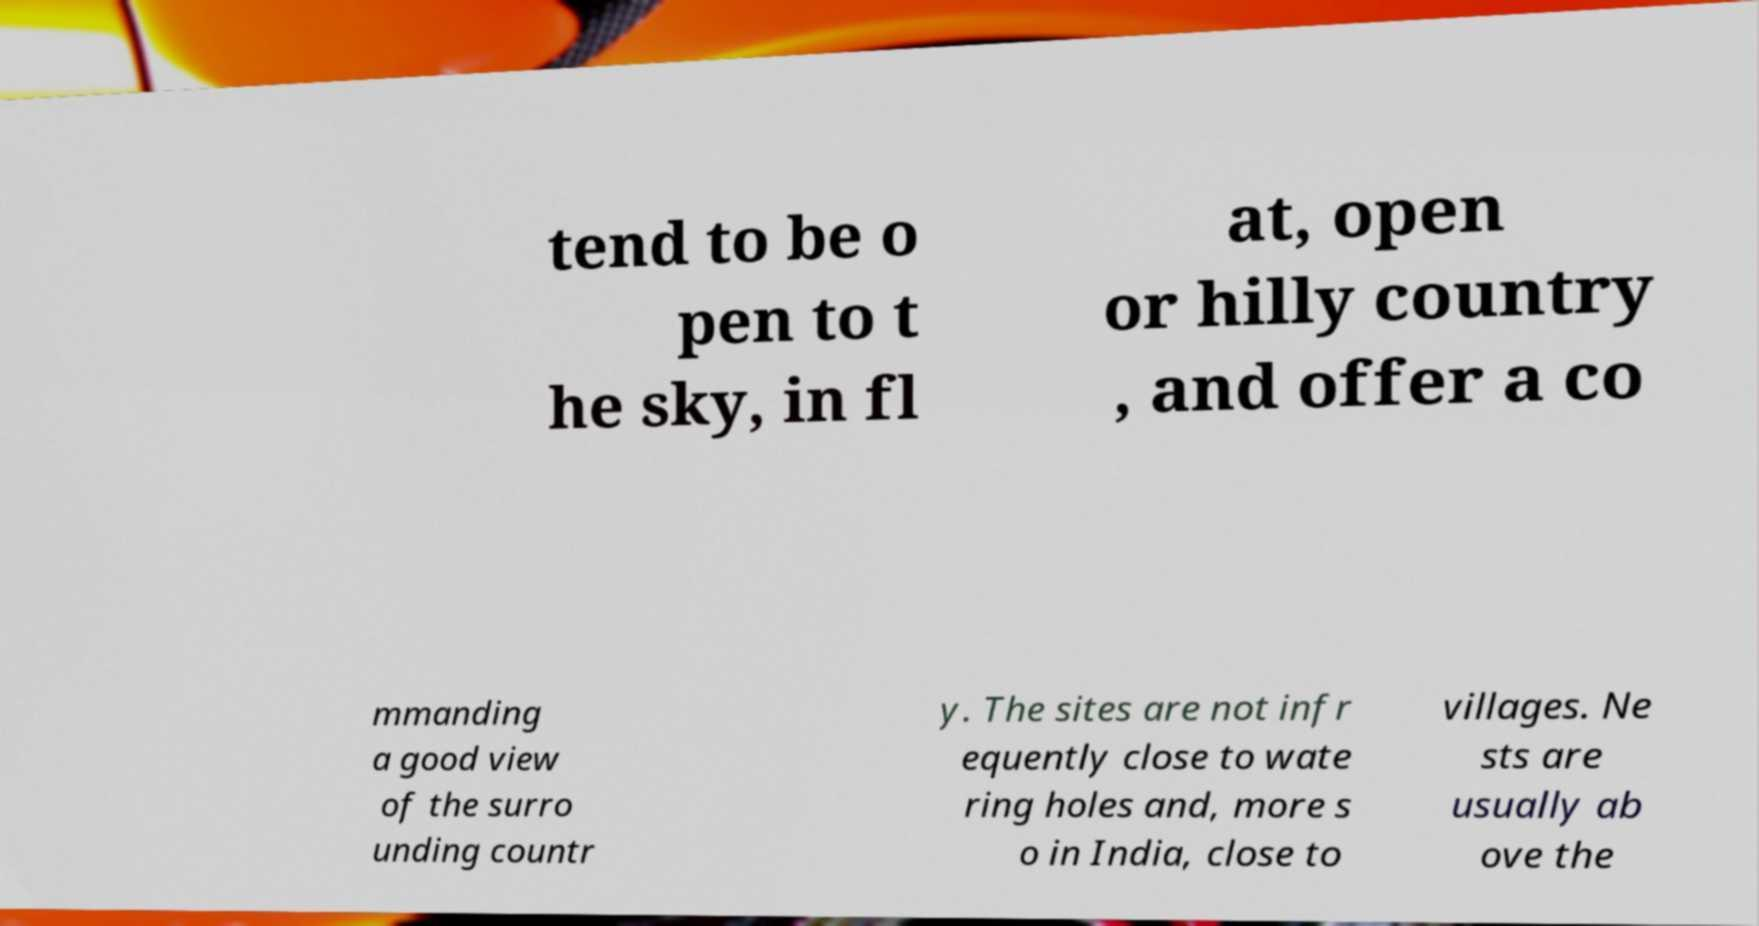Please identify and transcribe the text found in this image. tend to be o pen to t he sky, in fl at, open or hilly country , and offer a co mmanding a good view of the surro unding countr y. The sites are not infr equently close to wate ring holes and, more s o in India, close to villages. Ne sts are usually ab ove the 